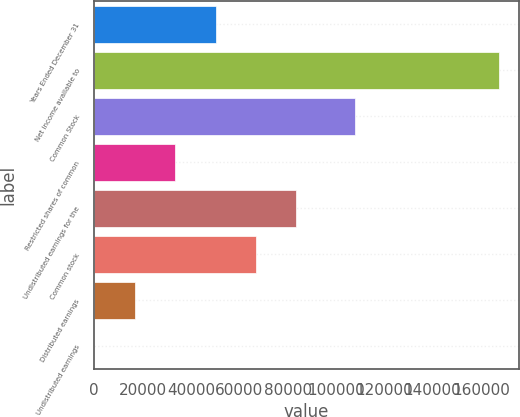Convert chart to OTSL. <chart><loc_0><loc_0><loc_500><loc_500><bar_chart><fcel>Years Ended December 31<fcel>Net income available to<fcel>Common Stock<fcel>Restricted shares of common<fcel>Undistributed earnings for the<fcel>Common stock<fcel>Distributed earnings<fcel>Undistributed earnings<nl><fcel>50210.9<fcel>167369<fcel>107880<fcel>33474<fcel>83684.6<fcel>66947.8<fcel>16737.1<fcel>0.27<nl></chart> 